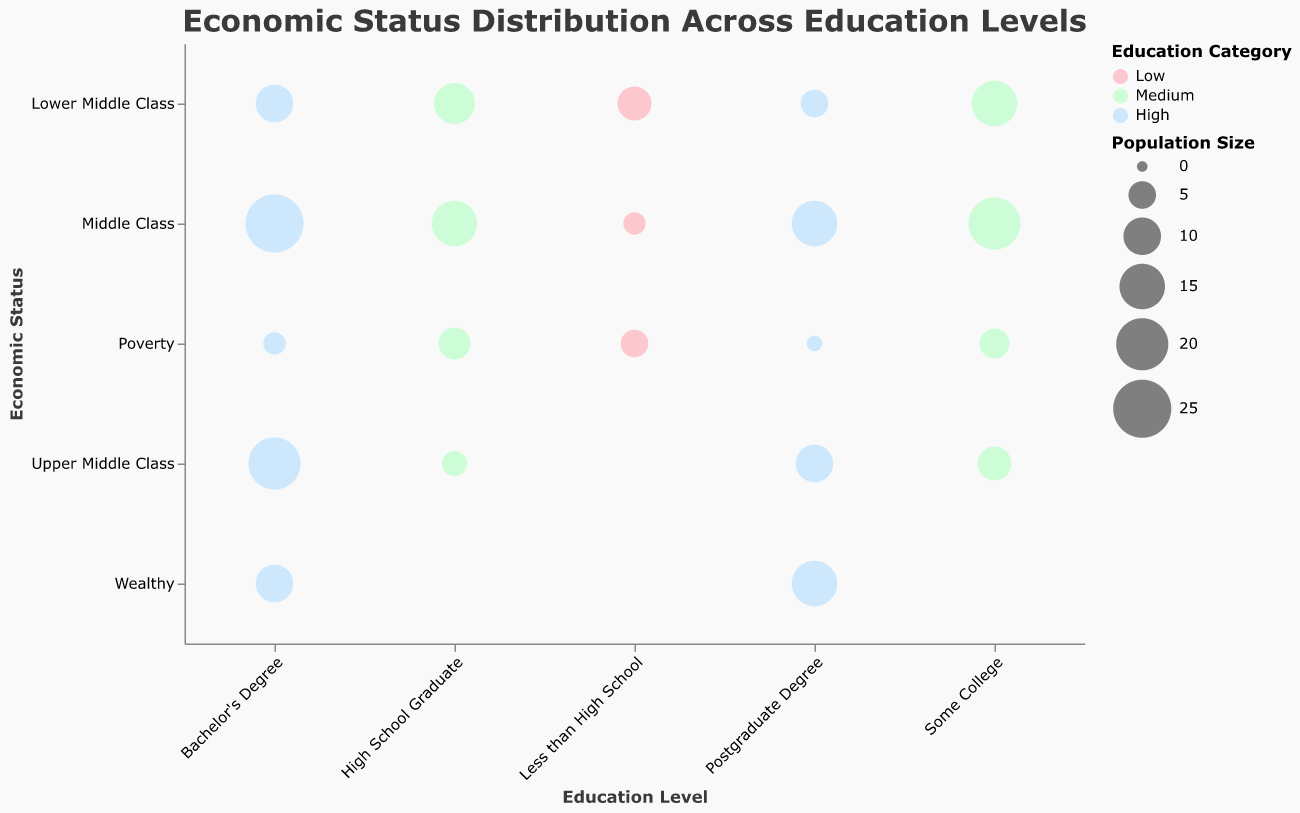What is the title of the chart? The text at the top of the chart clearly displays the title "Economic Status Distribution Across Education Levels" in a bold font.
Answer: Economic Status Distribution Across Education Levels Which education level has the largest bubble? The size of the bubble represents the population size. The largest bubble appears under "Bachelor's Degree" and "Middle Class" since it has the largest population size of 25.
Answer: Bachelor's Degree and Middle Class What is the income of the group with a Postgraduate Degree and classified as Wealthy? By looking at the y-axis label "Wealthy" and the x-axis label "Postgraduate Degree," we find the bubble, and the tooltip shows an income of $100,000 for this group.
Answer: $100,000 Which Economic Status category has the smallest population size within any education level? The smallest population size is 1, found in the "Postgraduate Degree" and "Poverty" category.
Answer: Poverty with Postgraduate Degree Between "High School Graduate" and "Some College," which education level has a higher population size in the Poverty category? We compare the population sizes of bubbles in the Poverty category for "High School Graduate" (7) and "Some College" (6). "High School Graduate" has a higher population size.
Answer: High School Graduate What is the relationship between Education Level and Economic Status based on bubble color? Bubbles are colored based on the Category: Low, Medium, or High. Lower education levels show mainly Low and Medium categories; higher education levels show Medium and High categories.
Answer: Lower education levels are mainly Low and Medium; higher education levels are mainly Medium and High How does the population size of the Upper Middle Class change with higher education levels? As we move from "Less than High School" to "Postgraduate Degree," the population size of Upper Middle Class increases from 4 to 10 and finally to 10. This indicates a positive trend.
Answer: Population size increases with higher education levels Which economic status category has the most diverse population size distribution across education levels? By examining the range of bubble sizes, "Middle Class" shows variations from smaller bubbles in lower education levels (3 for "Less than High School") to larger ones in higher education levels (25 for "Bachelor's degree").
Answer: Middle Class Which bubble has the highest income within the "Bachelor's Degree" education level? The tooltip for the bubbles under "Bachelor's Degree" shows that the "Wealthy" status has the highest income of $90,000.
Answer: Wealthy with $90,000 